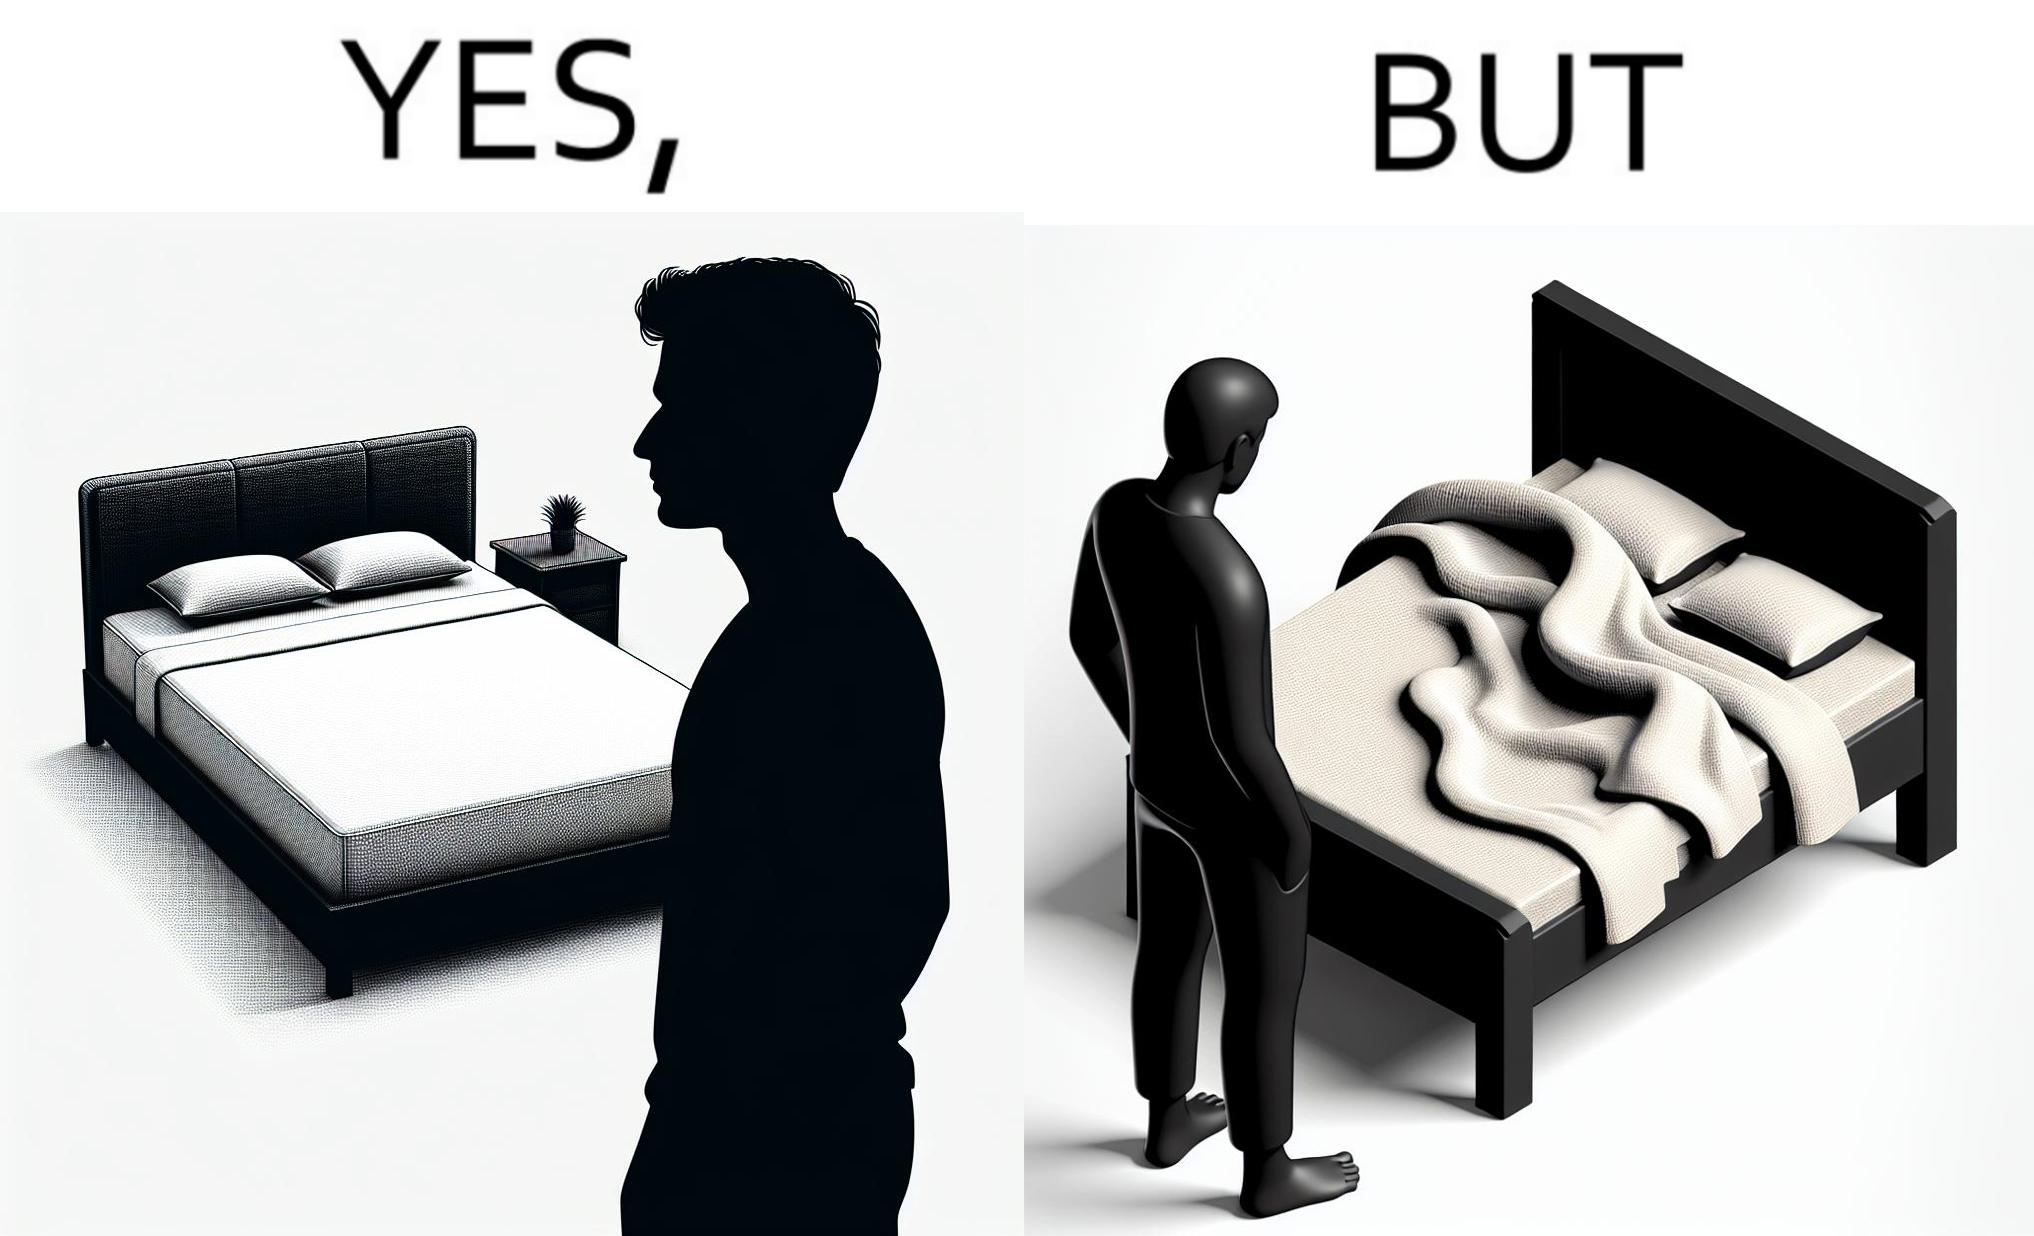Is this a satirical image? Yes, this image is satirical. 